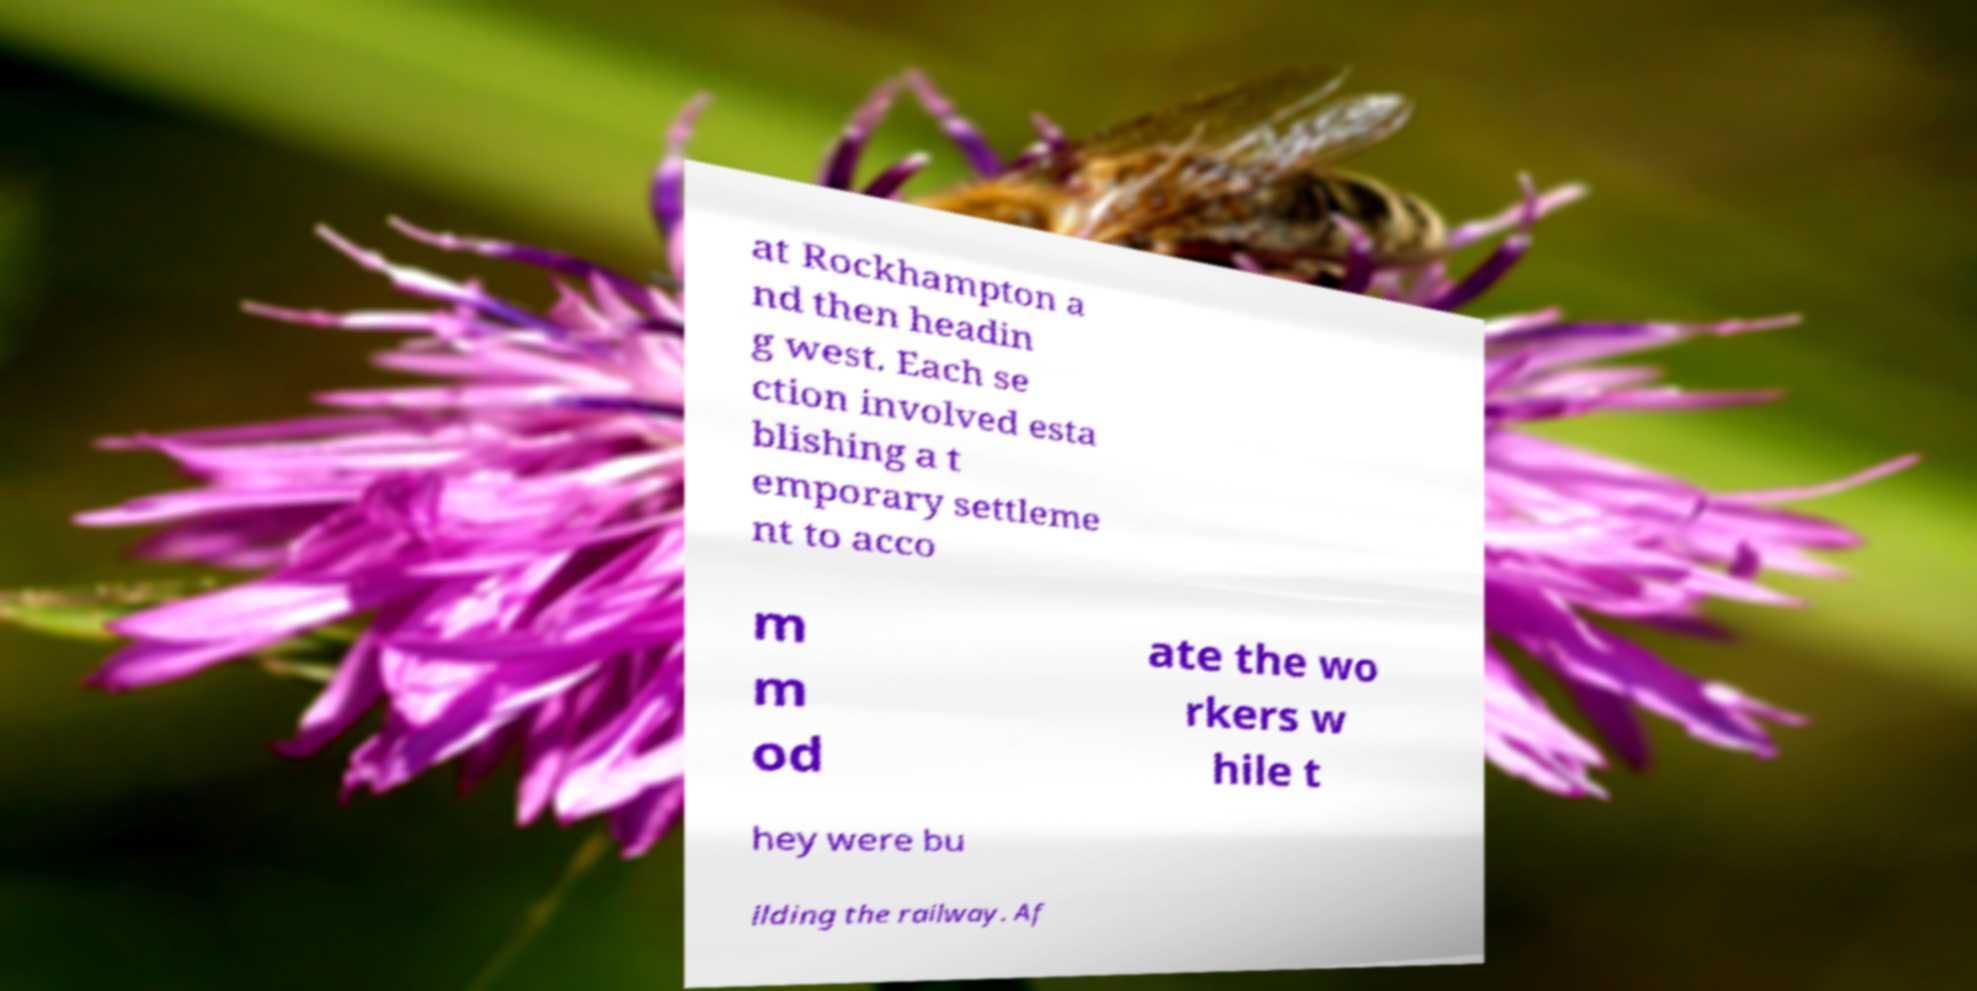There's text embedded in this image that I need extracted. Can you transcribe it verbatim? at Rockhampton a nd then headin g west. Each se ction involved esta blishing a t emporary settleme nt to acco m m od ate the wo rkers w hile t hey were bu ilding the railway. Af 